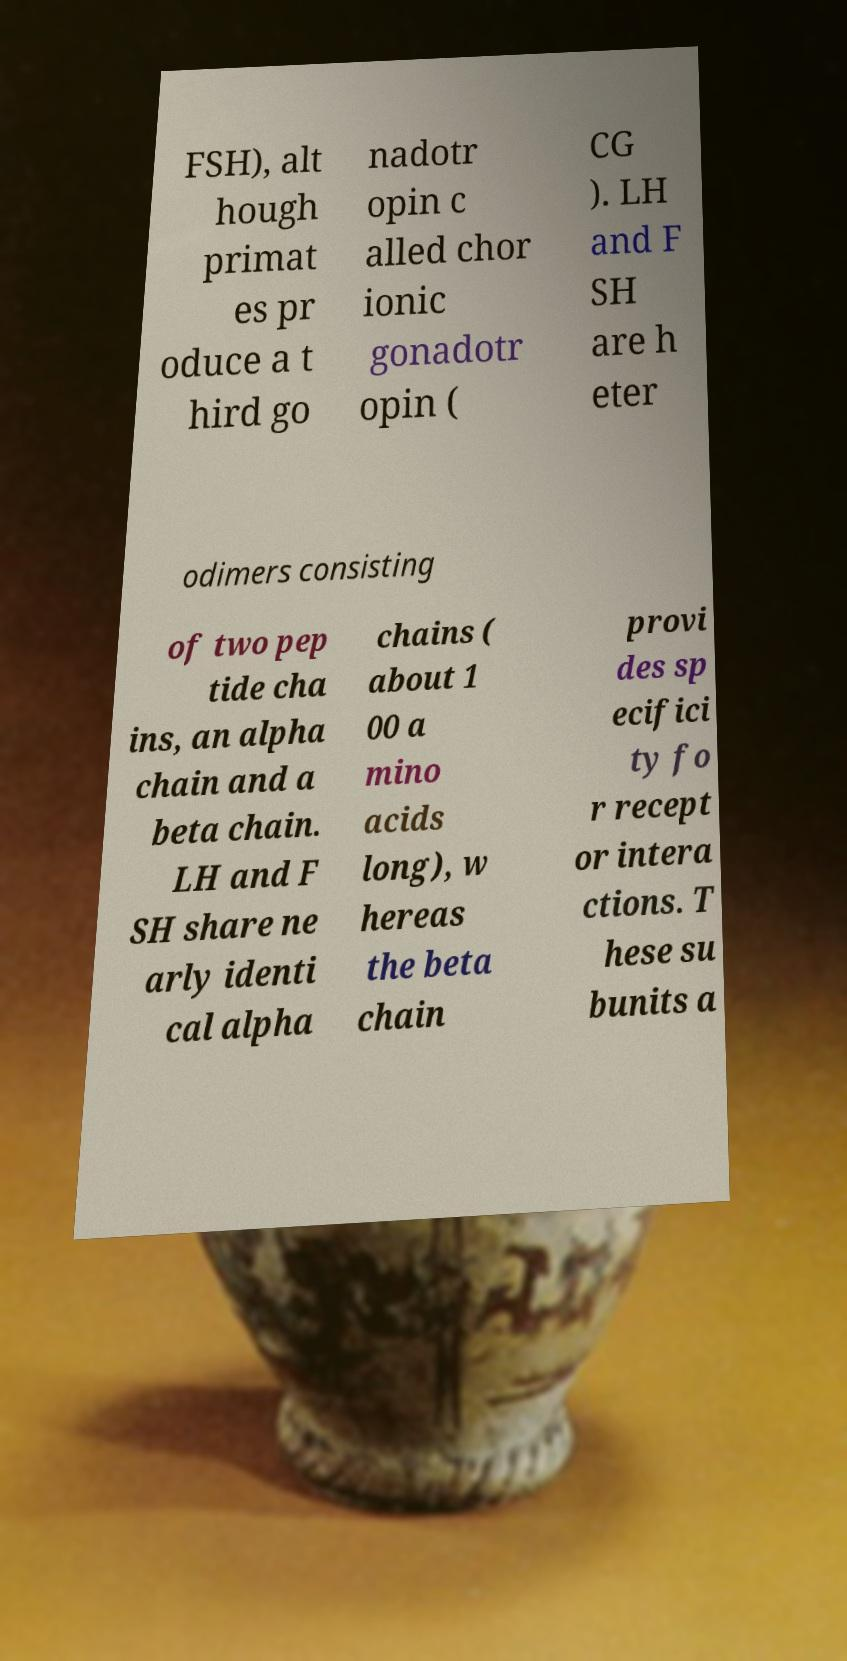Please read and relay the text visible in this image. What does it say? FSH), alt hough primat es pr oduce a t hird go nadotr opin c alled chor ionic gonadotr opin ( CG ). LH and F SH are h eter odimers consisting of two pep tide cha ins, an alpha chain and a beta chain. LH and F SH share ne arly identi cal alpha chains ( about 1 00 a mino acids long), w hereas the beta chain provi des sp ecifici ty fo r recept or intera ctions. T hese su bunits a 